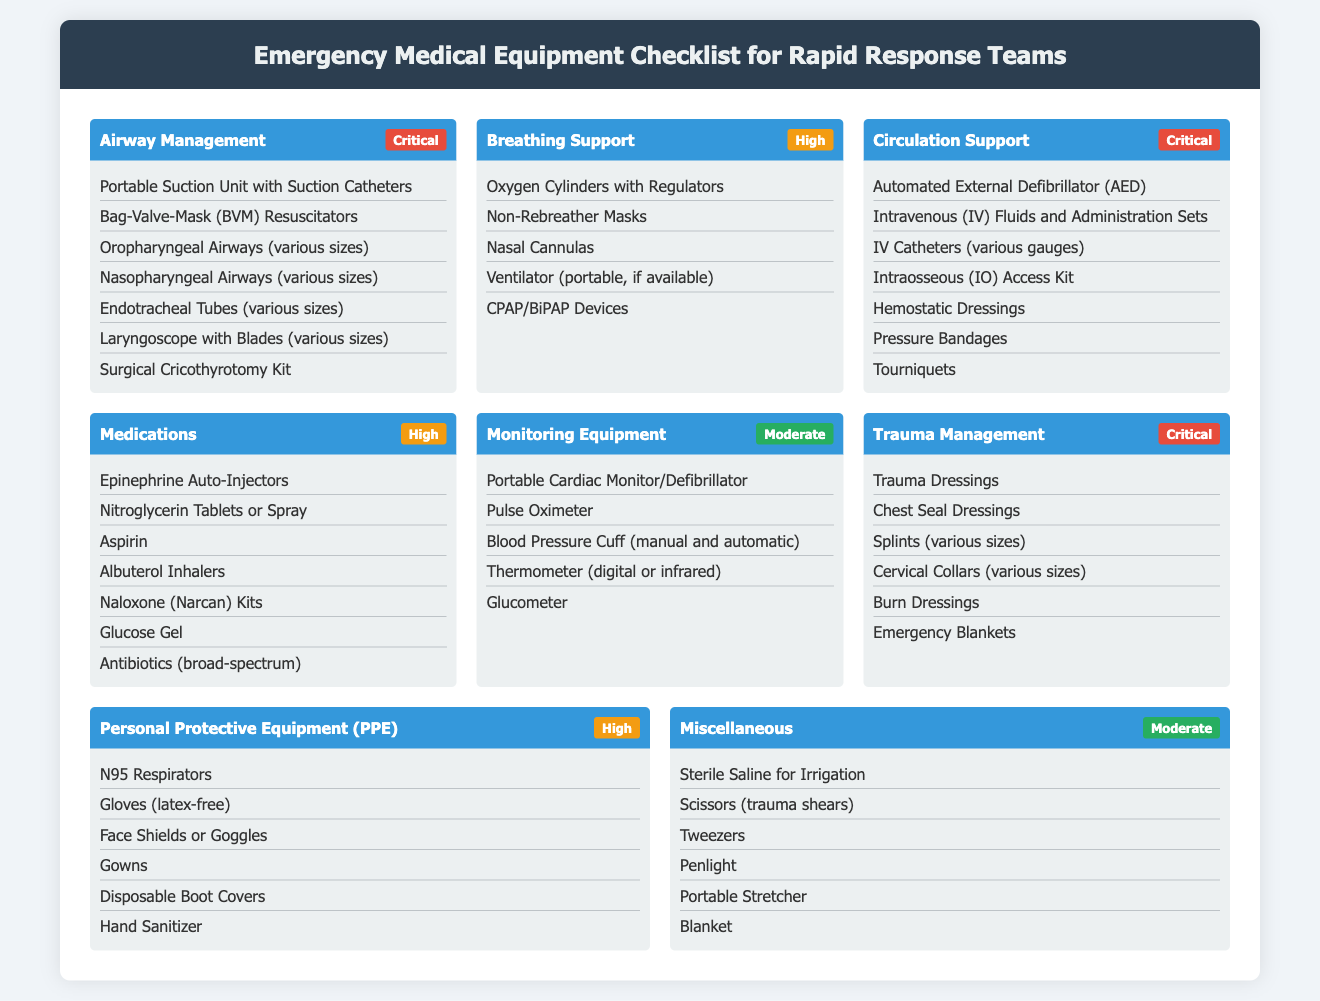What is the first category in the checklist? The first category in the checklist is listed at the top of the document under "Airway Management."
Answer: Airway Management How many items are in the "Breathing Support" category? The "Breathing Support" category contains five listed items.
Answer: 5 Which item in the "Circulation Support" category is used to stop bleeding? "Hemostatic Dressings" is identified as an item used for managing bleeding.
Answer: Hemostatic Dressings What urgency level is assigned to "Trauma Management"? The urgency level for "Trauma Management" is explicitly stated as Critical.
Answer: Critical How many types of airways are listed in "Airway Management"? The "Airway Management" category lists four different types of airways.
Answer: 4 Which department is emphasized in the highest urgency? The categories with Critical urgency are "Airway Management," "Circulation Support," and "Trauma Management."
Answer: Airway Management, Circulation Support, Trauma Management What type of masks are found in the "Breathing Support" category? "Non-Rebreather Masks" are specifically mentioned within the "Breathing Support" category.
Answer: Non-Rebreather Masks What type of gloves are included in Personal Protective Equipment? The gloves included fall under the specification of "latex-free."
Answer: latex-free Which category contains the "Portable Cardiac Monitor"? The item "Portable Cardiac Monitor/Defibrillator" is included in the "Monitoring Equipment" category.
Answer: Monitoring Equipment 